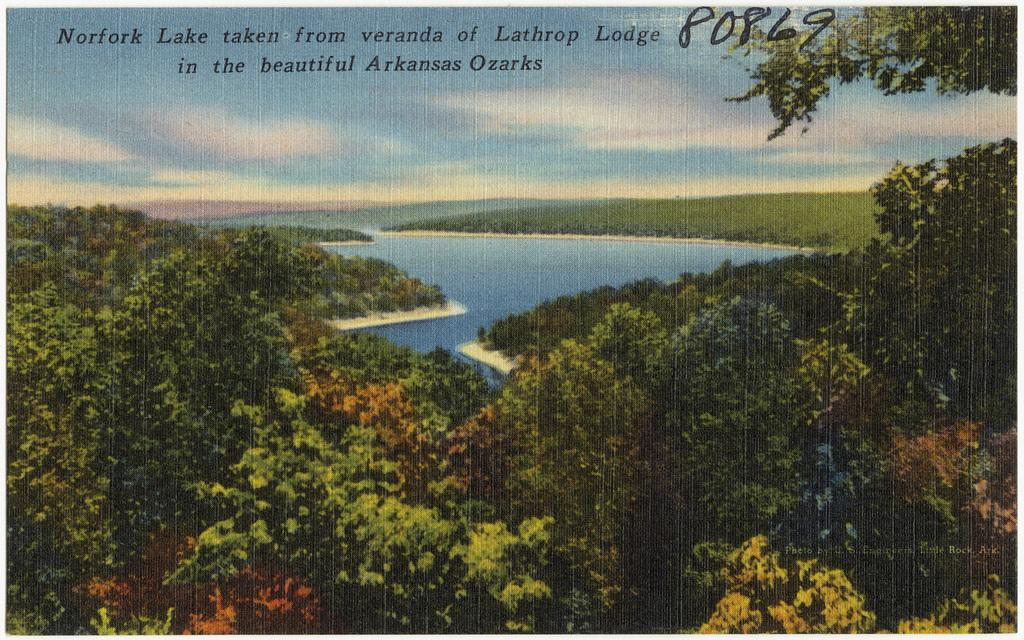What type of vegetation can be seen in the image? There are trees in the image. What can be seen in the background of the image? There is water and clouds in the sky visible in the background of the image. Is there any text present in the image? Yes, there is text written on the image. Can you tell me how many ministers are smiling in the image? There are no ministers or smiles present in the image. What type of mint is growing near the water in the image? There is no mint visible in the image; only trees, water, and clouds are present. 